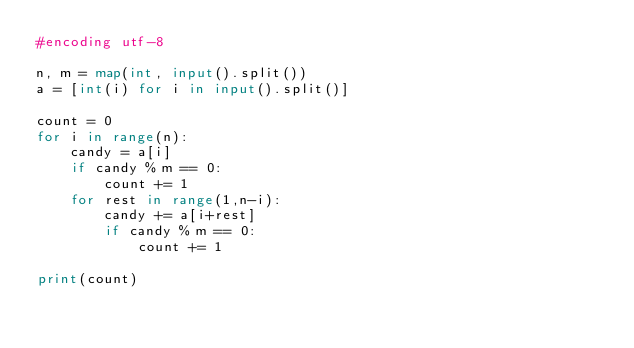Convert code to text. <code><loc_0><loc_0><loc_500><loc_500><_Python_>#encoding utf-8

n, m = map(int, input().split())
a = [int(i) for i in input().split()]

count = 0
for i in range(n):
    candy = a[i]
    if candy % m == 0:
        count += 1
    for rest in range(1,n-i):
        candy += a[i+rest]
        if candy % m == 0:
            count += 1

print(count)
</code> 